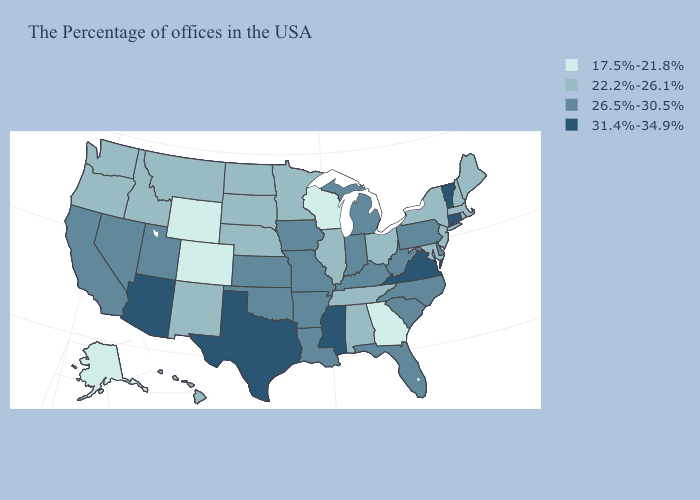Does Arizona have the highest value in the West?
Give a very brief answer. Yes. Name the states that have a value in the range 26.5%-30.5%?
Answer briefly. Delaware, Pennsylvania, North Carolina, South Carolina, West Virginia, Florida, Michigan, Kentucky, Indiana, Louisiana, Missouri, Arkansas, Iowa, Kansas, Oklahoma, Utah, Nevada, California. What is the lowest value in the USA?
Quick response, please. 17.5%-21.8%. What is the value of Kansas?
Write a very short answer. 26.5%-30.5%. What is the value of California?
Write a very short answer. 26.5%-30.5%. Among the states that border Rhode Island , does Massachusetts have the lowest value?
Concise answer only. Yes. Name the states that have a value in the range 17.5%-21.8%?
Keep it brief. Georgia, Wisconsin, Wyoming, Colorado, Alaska. Name the states that have a value in the range 22.2%-26.1%?
Give a very brief answer. Maine, Massachusetts, Rhode Island, New Hampshire, New York, New Jersey, Maryland, Ohio, Alabama, Tennessee, Illinois, Minnesota, Nebraska, South Dakota, North Dakota, New Mexico, Montana, Idaho, Washington, Oregon, Hawaii. Among the states that border Montana , which have the lowest value?
Short answer required. Wyoming. Among the states that border Washington , which have the lowest value?
Give a very brief answer. Idaho, Oregon. What is the value of New Hampshire?
Be succinct. 22.2%-26.1%. Which states have the lowest value in the MidWest?
Quick response, please. Wisconsin. What is the lowest value in the USA?
Give a very brief answer. 17.5%-21.8%. What is the value of Ohio?
Keep it brief. 22.2%-26.1%. Does Wyoming have the lowest value in the West?
Short answer required. Yes. 